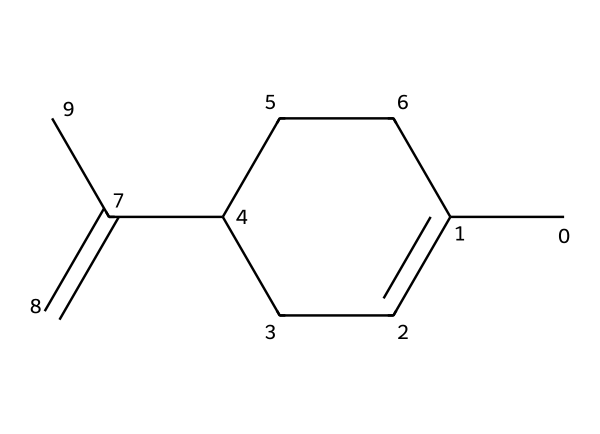What is the molecular formula of limonene? To find the molecular formula, count the number of each type of atom in the SMILES representation. The structure indicates there are 10 carbon (C) atoms and 16 hydrogen (H) atoms. Therefore, the molecular formula is C10H16.
Answer: C10H16 How many carbon-carbon double bonds are present in limonene? Inspecting the structure, a double bond can be identified between specific carbon atoms (C1=C2). The analysis shows there is 1 carbon-carbon double bond in the molecule.
Answer: 1 What type of compound is limonene classified as? The structure falls under the category of aliphatic compounds, specifically a cyclic terpene hydrocarbon, characterized by its open and cyclic carbon chain structure.
Answer: aliphatic How many rings are in limonene? Analyzing the cyclic portion of the structure reveals there is one ring formed by the carbon atoms within the compound.
Answer: 1 What is the degree of unsaturation in limonene? The degree of unsaturation can be calculated based on the formula: (2C + 2 - H) / 2. Plugging in the values (2*10 + 2 - 16) / 2 yields 3, indicating there are three sites of unsaturation, which includes the double bond and the ring structure.
Answer: 3 What functional groups are present in limonene? By examining the SMILES and structure, it is determined that limonene primarily exhibits aliphatic characteristics and lacks functional groups like hydroxyl or carboxyl, as it contains only carbon and hydrogen atoms.
Answer: none 